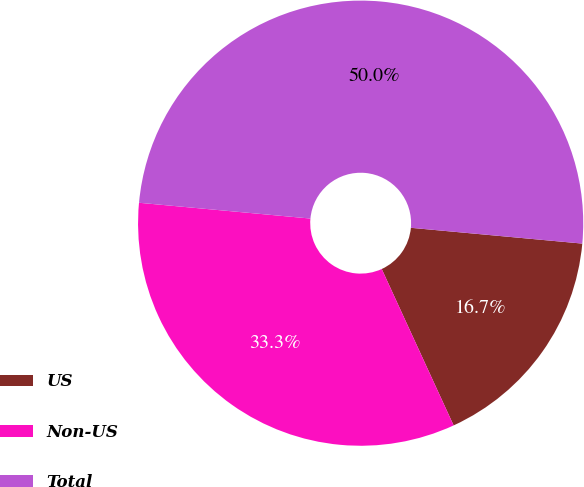<chart> <loc_0><loc_0><loc_500><loc_500><pie_chart><fcel>US<fcel>Non-US<fcel>Total<nl><fcel>16.68%<fcel>33.32%<fcel>50.0%<nl></chart> 